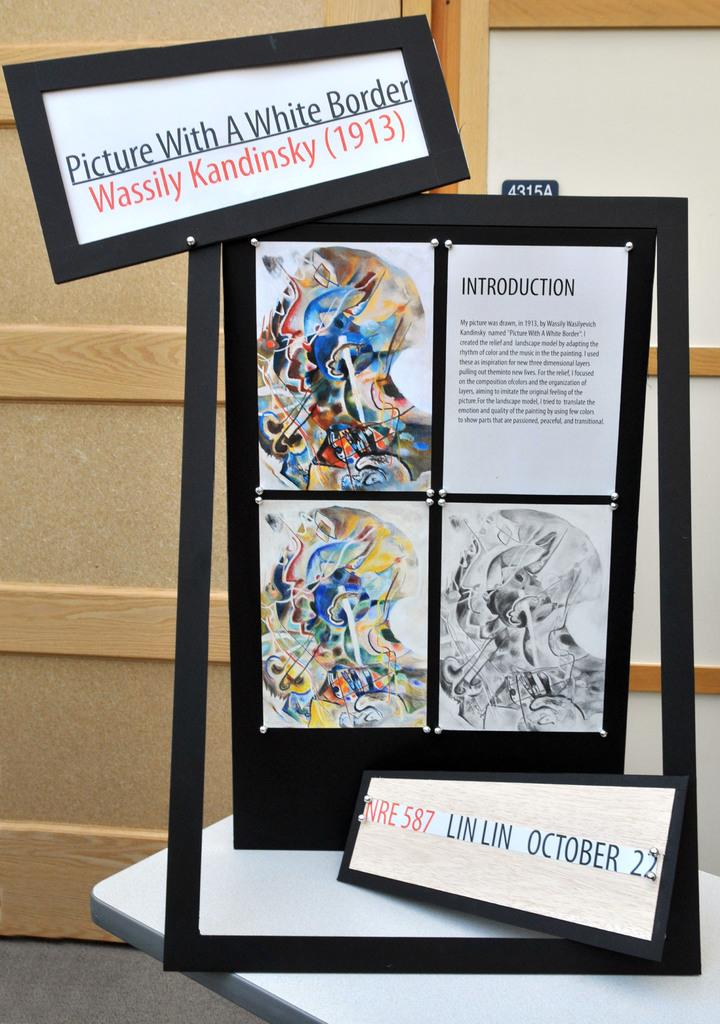What objects are on the table in the image? There are frames on the table in the image. Can you read any text in the image? Yes, there is some text visible in the image. What scent can be detected from the frames in the image? There is no information about the scent of the frames in the image, as it is not a sensory detail that can be observed visually. 